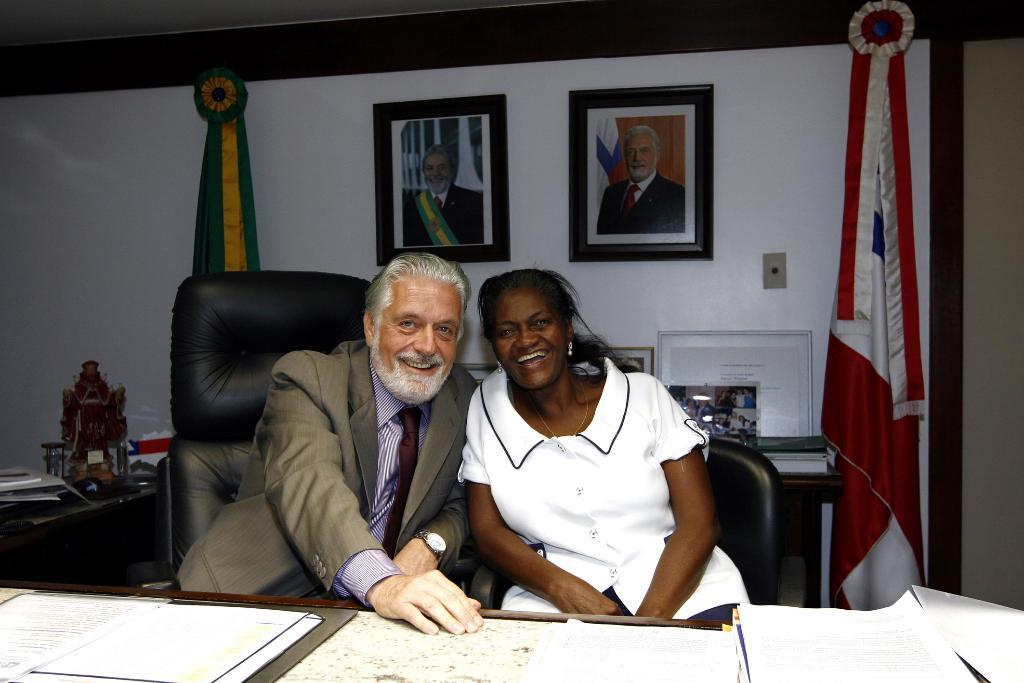How many people are in the image? There are two people in the image. What are the people doing in the image? The people are sitting on chairs. What can be seen in the background of the image? There is a wall in the background of the image. What is hanging on the wall in the image? There are two photo frames on the wall. What type of lettuce is being used to clean the people's mouths in the image? There is no lettuce present in the image, nor is there any indication that the people's mouths are being cleaned. 